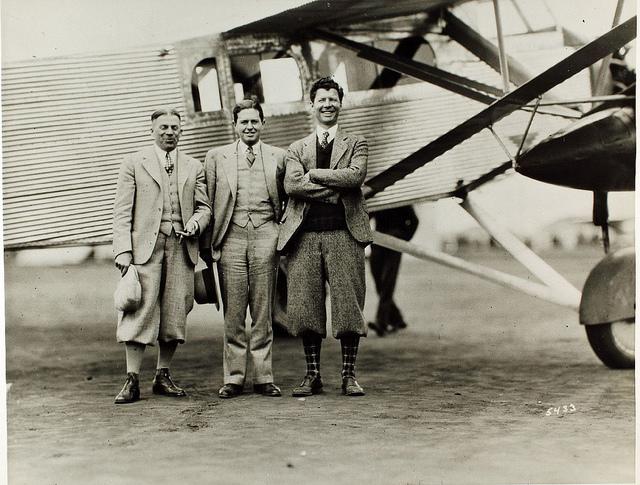What are the men standing on?
Short answer required. Ground. What are they standing next to?
Concise answer only. Plane. How many men are shown?
Answer briefly. 3. 